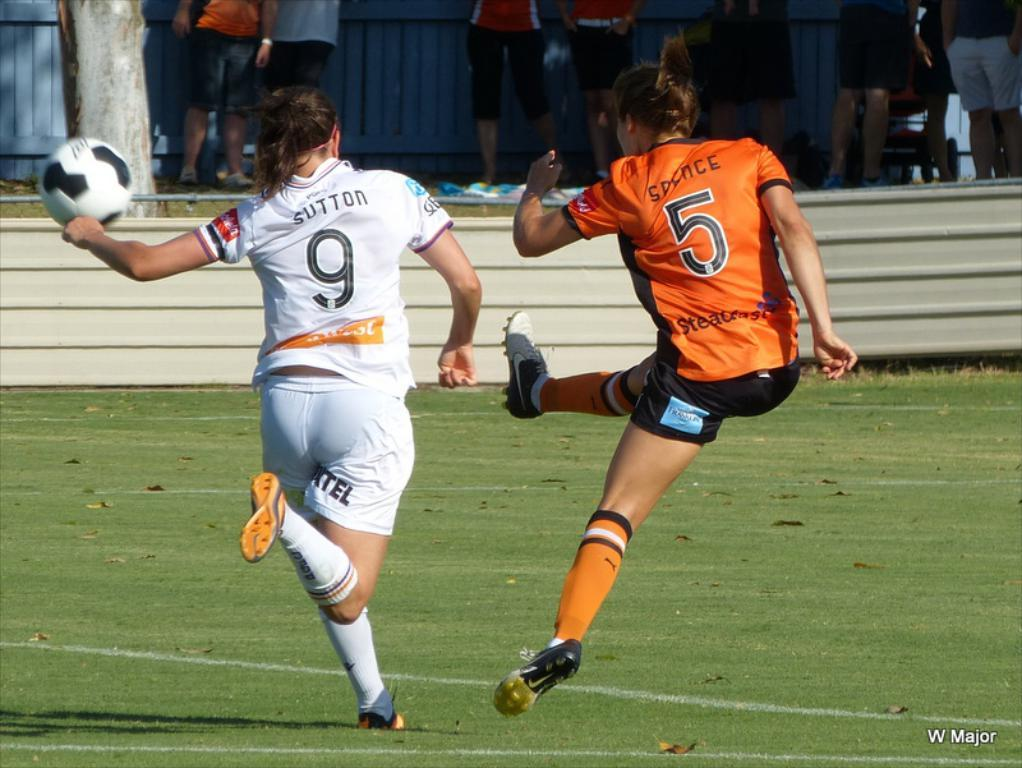<image>
Offer a succinct explanation of the picture presented. Two women soccer players, Sutton #9 and Spence #5 compete for the ball on the field. 